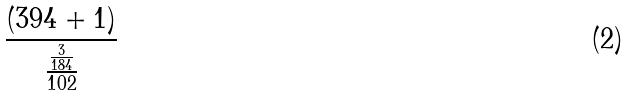<formula> <loc_0><loc_0><loc_500><loc_500>\frac { ( 3 9 4 + 1 ) } { \frac { \frac { 3 } { 1 8 4 } } { 1 0 2 } }</formula> 